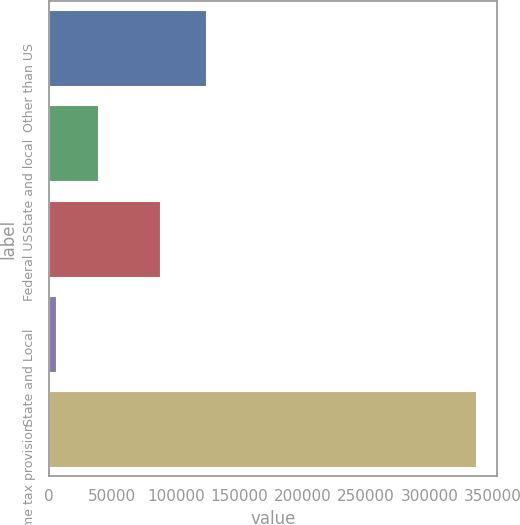Convert chart. <chart><loc_0><loc_0><loc_500><loc_500><bar_chart><fcel>Other than US<fcel>State and local<fcel>Federal US<fcel>State and Local<fcel>Income tax provision<nl><fcel>124160<fcel>38565.6<fcel>87561<fcel>5446<fcel>336642<nl></chart> 